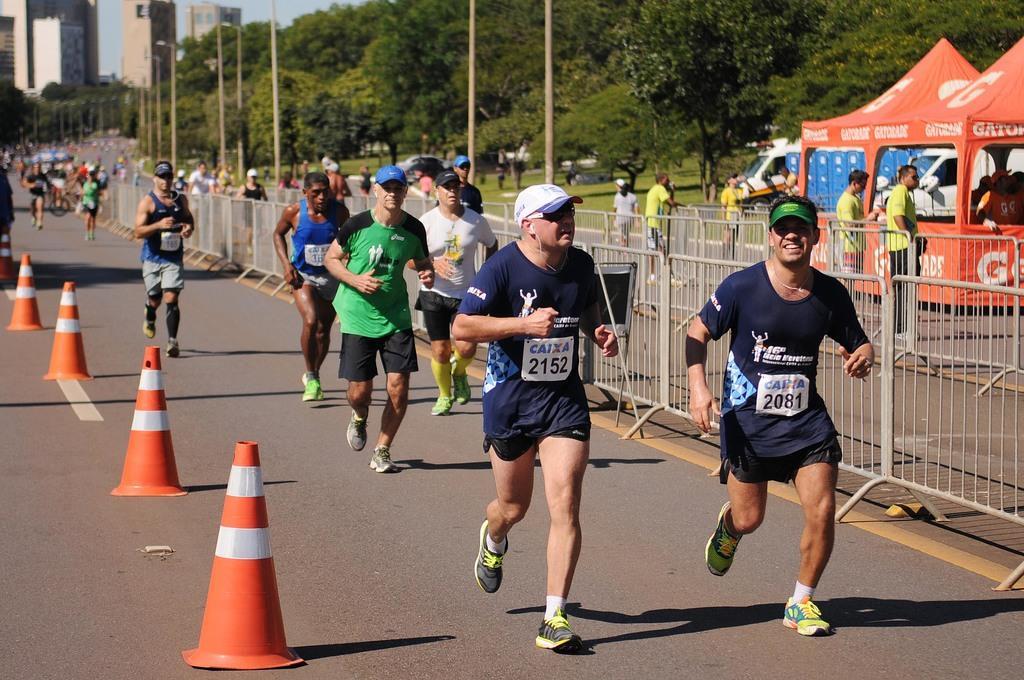Can you describe this image briefly? In this image, we can see people running on the road and there are traffic cones. In the background, we can see trees, buildings, poles, tents, some vehicles and there is a fence. 